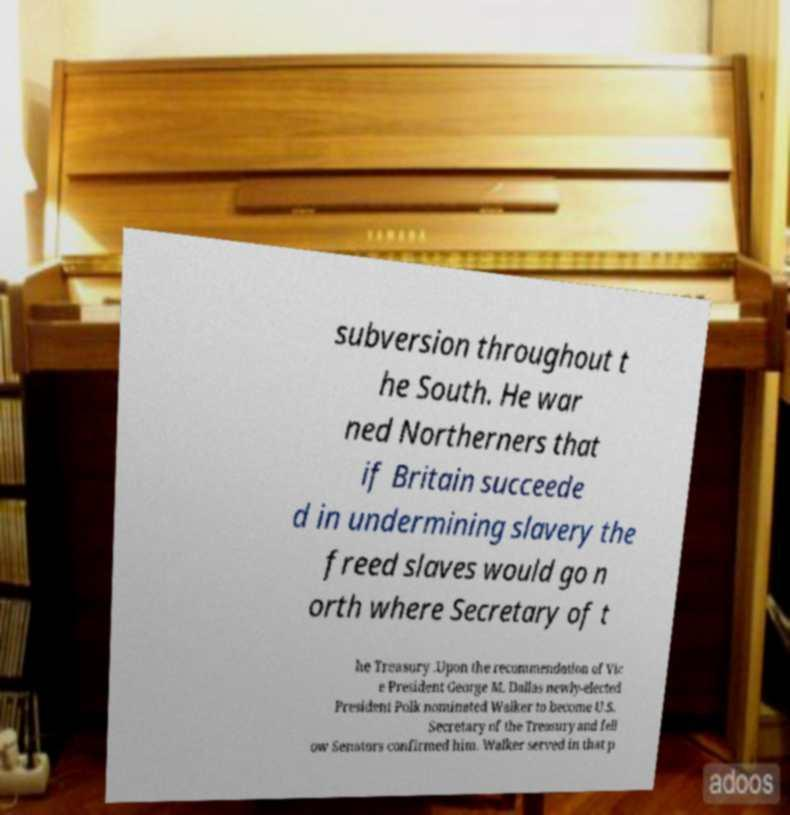What messages or text are displayed in this image? I need them in a readable, typed format. subversion throughout t he South. He war ned Northerners that if Britain succeede d in undermining slavery the freed slaves would go n orth where Secretary of t he Treasury .Upon the recommendation of Vic e President George M. Dallas newly-elected President Polk nominated Walker to become U.S. Secretary of the Treasury and fell ow Senators confirmed him. Walker served in that p 